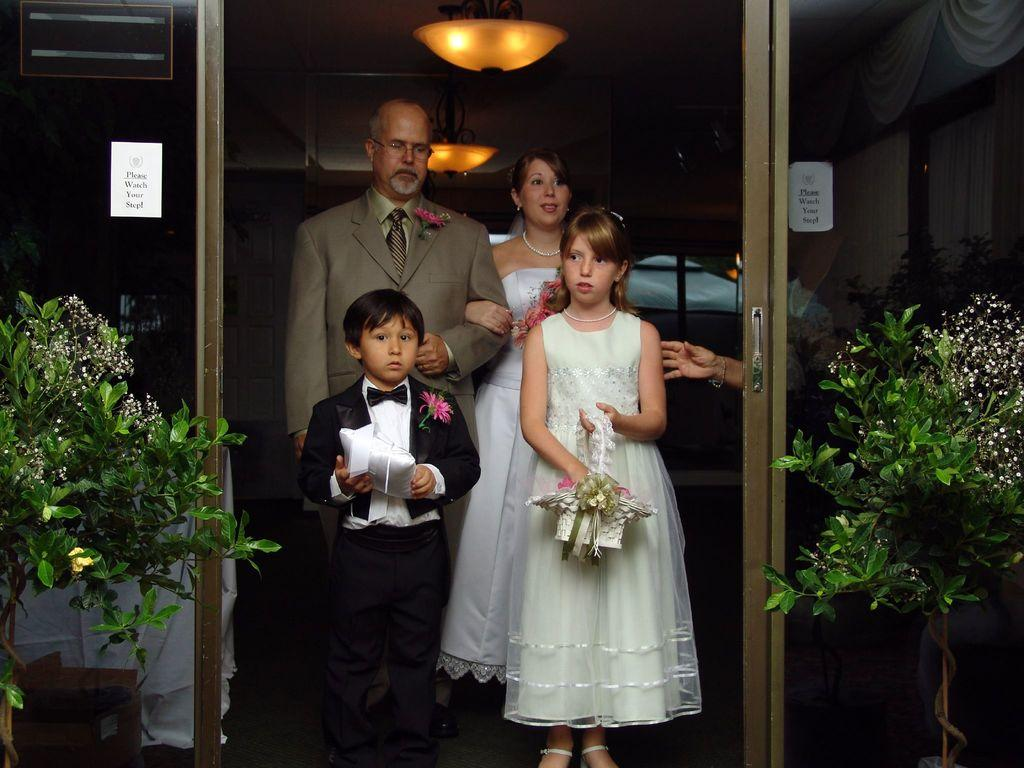How many people are in the group visible in the image? There is a group of people in the image, but the exact number cannot be determined without more specific information. What type of vegetation is present in the image? There are plants in the image. Can you describe the light in the image? Yes, there is a light in the image. What type of cough medicine is the porter carrying in the image? There is no porter or cough medicine present in the image. What color is the thread used to sew the plants in the image? There is no thread or indication of sewing in the image; it features a group of people, plants, and a light. 